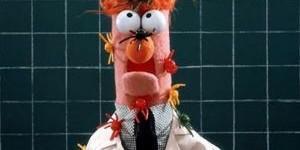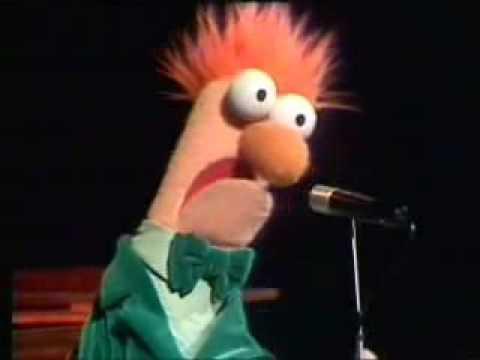The first image is the image on the left, the second image is the image on the right. For the images displayed, is the sentence "The puppet is facing to the right in the image on the right." factually correct? Answer yes or no. Yes. 